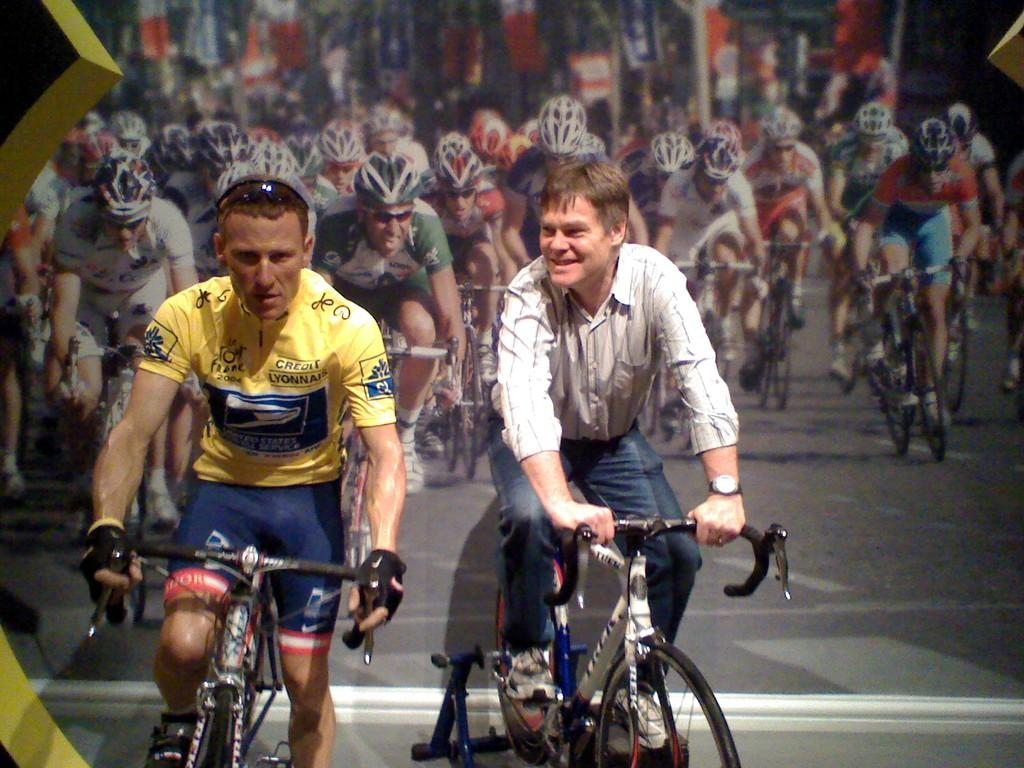What are the two main subjects in the image? There are two men riding bicycles in the image. Can you describe the background of the image? In the background, there are other men riding bicycles. Where is the sheep sitting on the throne in the image? There is no sheep or throne present in the image; it only features men riding bicycles. 